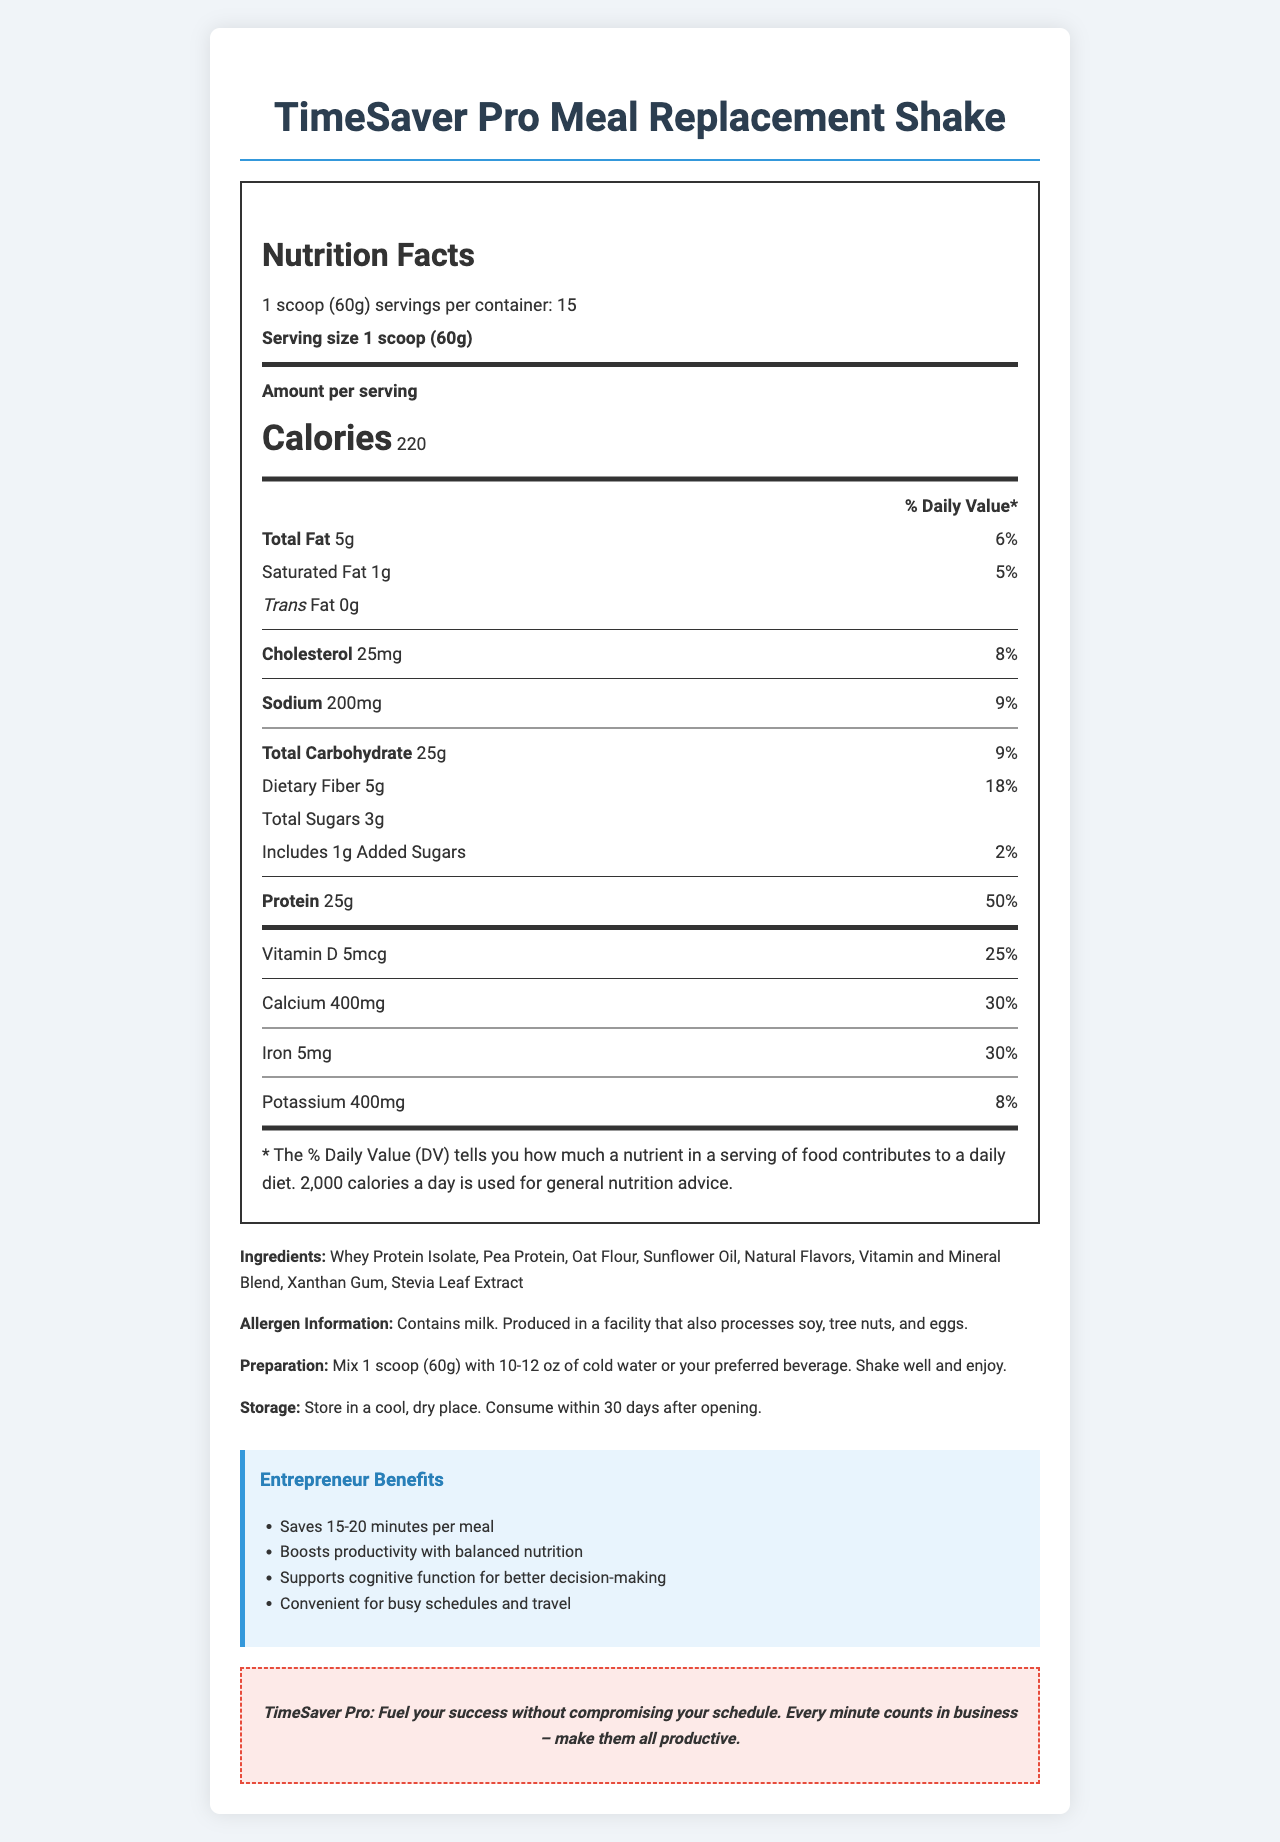what is the serving size of the TimeSaver Pro Meal Replacement Shake? The serving size is explicitly mentioned as 1 scoop (60g) in the nutrition facts section.
Answer: 1 scoop (60g) how many calories are in one serving? The calories per serving are listed as 220 in the nutrition facts section.
Answer: 220 how much protein is in each serving? The protein amount per serving is listed as 25g in the nutrition facts section.
Answer: 25g what is the % Daily Value for dietary fiber per serving? The % Daily Value for dietary fiber is listed as 18% in the nutrition facts section.
Answer: 18% how long should the product be consumed after opening? The product should be consumed within 30 days after opening, as mentioned in the storage instructions.
Answer: 30 days how many servings are in one container? A. 10 B. 15 C. 20 The document mentions there are 15 servings per container.
Answer: B. 15 which of the following is an ingredient? I. Whey Protein Isolate II. Sugar III. Corn Syrup IV. Natural Flavors The ingredient list includes Whey Protein Isolate and Natural Flavors but does not mention Sugar or Corn Syrup.
Answer: I and IV does the product contain any allergens? The allergen information states that the product contains milk and is produced in a facility that processes soy, tree nuts, and eggs.
Answer: Yes does TimeSaver Pro Meal Replacement Shake contain any trans fat? The Trans Fat amount is listed as 0g in the nutrition facts section.
Answer: No summarize the main purpose and benefits of the TimeSaver Pro Meal Replacement Shake. The document emphasizes that the product saves 15-20 minutes per meal, boosts productivity, supports cognitive function, and is convenient for busy schedules and travel.
Answer: The TimeSaver Pro Meal Replacement Shake is designed to save time for busy entrepreneurs by providing balanced nutrition in a convenient format. It helps boost productivity, supports cognitive function, and is ideal for travel. what is the origin of the whey protein isolate used in the product? The document does not provide information on the origin of the whey protein isolate.
Answer: Not enough information 